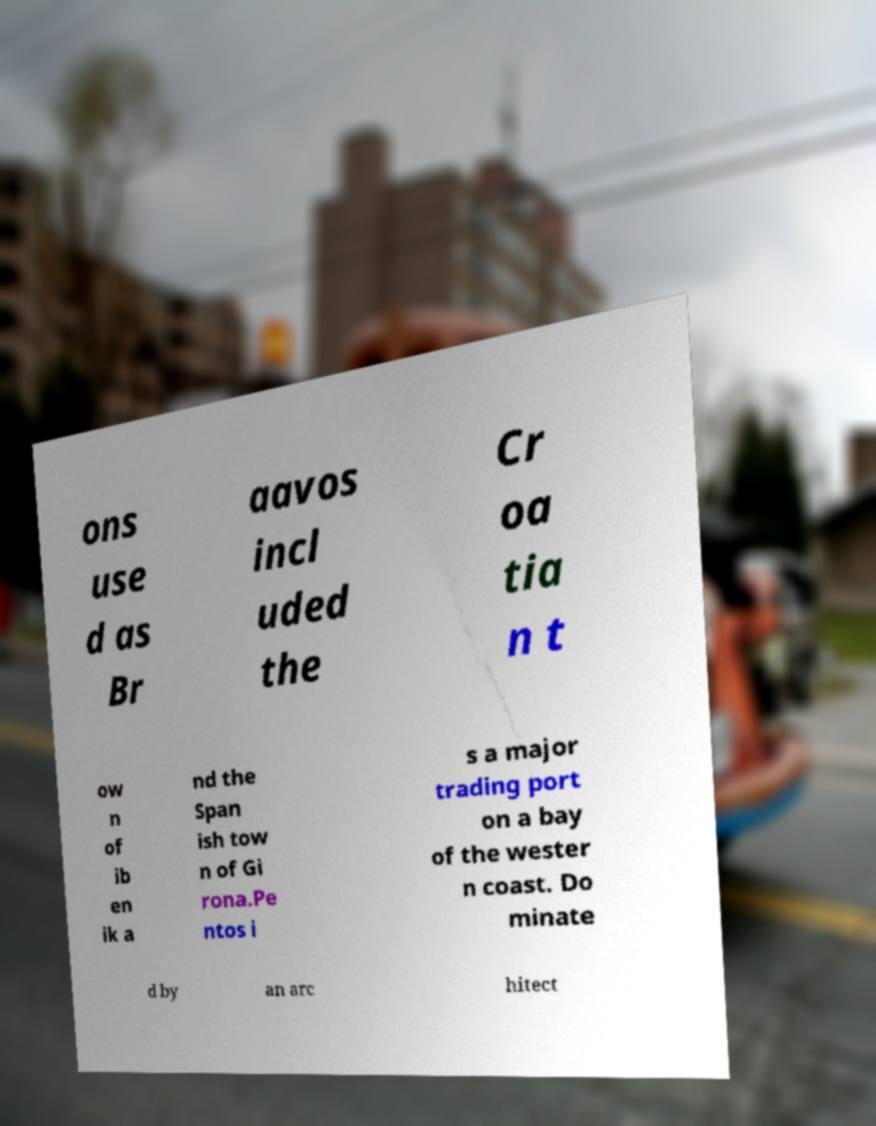Can you accurately transcribe the text from the provided image for me? ons use d as Br aavos incl uded the Cr oa tia n t ow n of ib en ik a nd the Span ish tow n of Gi rona.Pe ntos i s a major trading port on a bay of the wester n coast. Do minate d by an arc hitect 